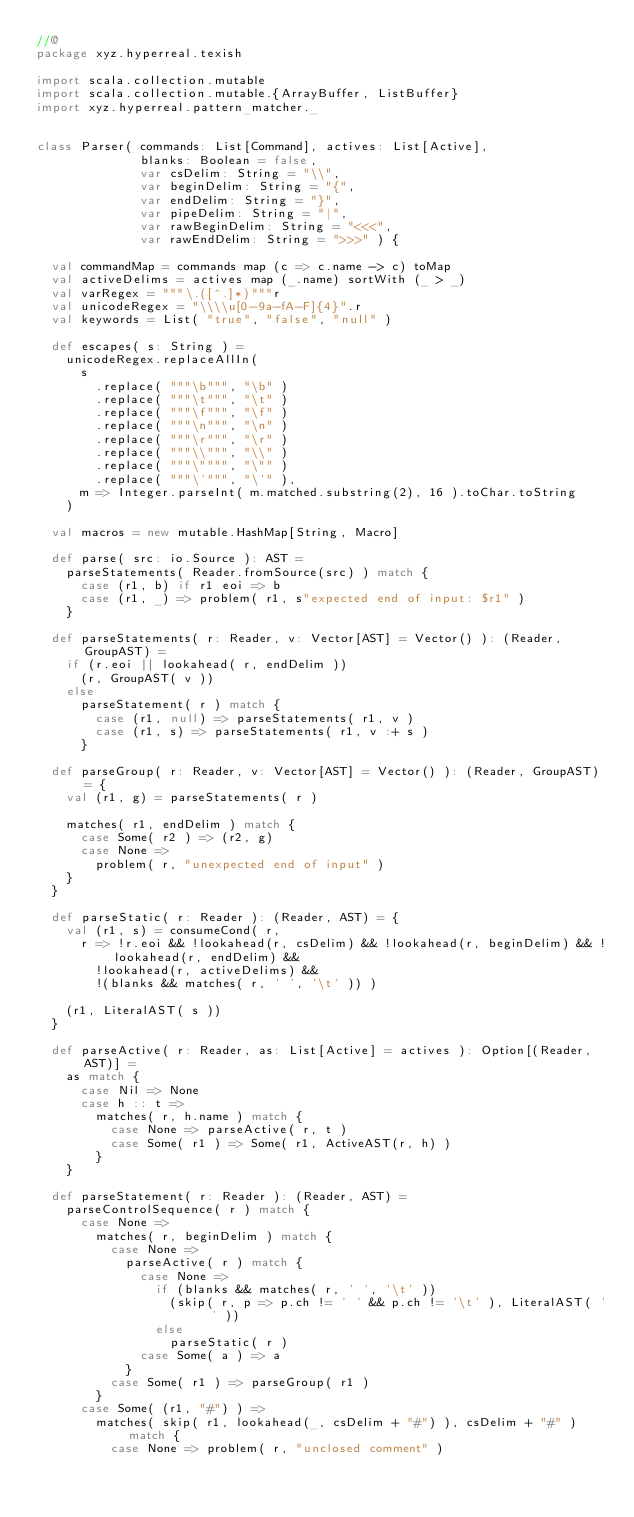<code> <loc_0><loc_0><loc_500><loc_500><_Scala_>//@
package xyz.hyperreal.texish

import scala.collection.mutable
import scala.collection.mutable.{ArrayBuffer, ListBuffer}
import xyz.hyperreal.pattern_matcher._


class Parser( commands: List[Command], actives: List[Active],
              blanks: Boolean = false,
              var csDelim: String = "\\",
              var beginDelim: String = "{",
              var endDelim: String = "}",
              var pipeDelim: String = "|",
              var rawBeginDelim: String = "<<<",
              var rawEndDelim: String = ">>>" ) {

  val commandMap = commands map (c => c.name -> c) toMap
  val activeDelims = actives map (_.name) sortWith (_ > _)
  val varRegex = """\.([^.]*)"""r
  val unicodeRegex = "\\\\u[0-9a-fA-F]{4}".r
  val keywords = List( "true", "false", "null" )

  def escapes( s: String ) =
    unicodeRegex.replaceAllIn(
      s
        .replace( """\b""", "\b" )
        .replace( """\t""", "\t" )
        .replace( """\f""", "\f" )
        .replace( """\n""", "\n" )
        .replace( """\r""", "\r" )
        .replace( """\\""", "\\" )
        .replace( """\"""", "\"" )
        .replace( """\'""", "\'" ),
      m => Integer.parseInt( m.matched.substring(2), 16 ).toChar.toString
    )

  val macros = new mutable.HashMap[String, Macro]

  def parse( src: io.Source ): AST =
    parseStatements( Reader.fromSource(src) ) match {
      case (r1, b) if r1 eoi => b
      case (r1, _) => problem( r1, s"expected end of input: $r1" )
    }

  def parseStatements( r: Reader, v: Vector[AST] = Vector() ): (Reader, GroupAST) =
    if (r.eoi || lookahead( r, endDelim ))
      (r, GroupAST( v ))
    else
      parseStatement( r ) match {
        case (r1, null) => parseStatements( r1, v )
        case (r1, s) => parseStatements( r1, v :+ s )
      }

  def parseGroup( r: Reader, v: Vector[AST] = Vector() ): (Reader, GroupAST) = {
    val (r1, g) = parseStatements( r )

    matches( r1, endDelim ) match {
      case Some( r2 ) => (r2, g)
      case None =>
        problem( r, "unexpected end of input" )
    }
  }

  def parseStatic( r: Reader ): (Reader, AST) = {
    val (r1, s) = consumeCond( r,
      r => !r.eoi && !lookahead(r, csDelim) && !lookahead(r, beginDelim) && !lookahead(r, endDelim) &&
        !lookahead(r, activeDelims) &&
        !(blanks && matches( r, ' ', '\t' )) )

    (r1, LiteralAST( s ))
  }

  def parseActive( r: Reader, as: List[Active] = actives ): Option[(Reader, AST)] =
    as match {
      case Nil => None
      case h :: t =>
        matches( r, h.name ) match {
          case None => parseActive( r, t )
          case Some( r1 ) => Some( r1, ActiveAST(r, h) )
        }
    }

  def parseStatement( r: Reader ): (Reader, AST) =
    parseControlSequence( r ) match {
      case None =>
        matches( r, beginDelim ) match {
          case None =>
            parseActive( r ) match {
              case None =>
                if (blanks && matches( r, ' ', '\t' ))
                  (skip( r, p => p.ch != ' ' && p.ch != '\t' ), LiteralAST( ' ' ))
                else
                  parseStatic( r )
              case Some( a ) => a
            }
          case Some( r1 ) => parseGroup( r1 )
        }
      case Some( (r1, "#") ) =>
        matches( skip( r1, lookahead(_, csDelim + "#") ), csDelim + "#" ) match {
          case None => problem( r, "unclosed comment" )</code> 